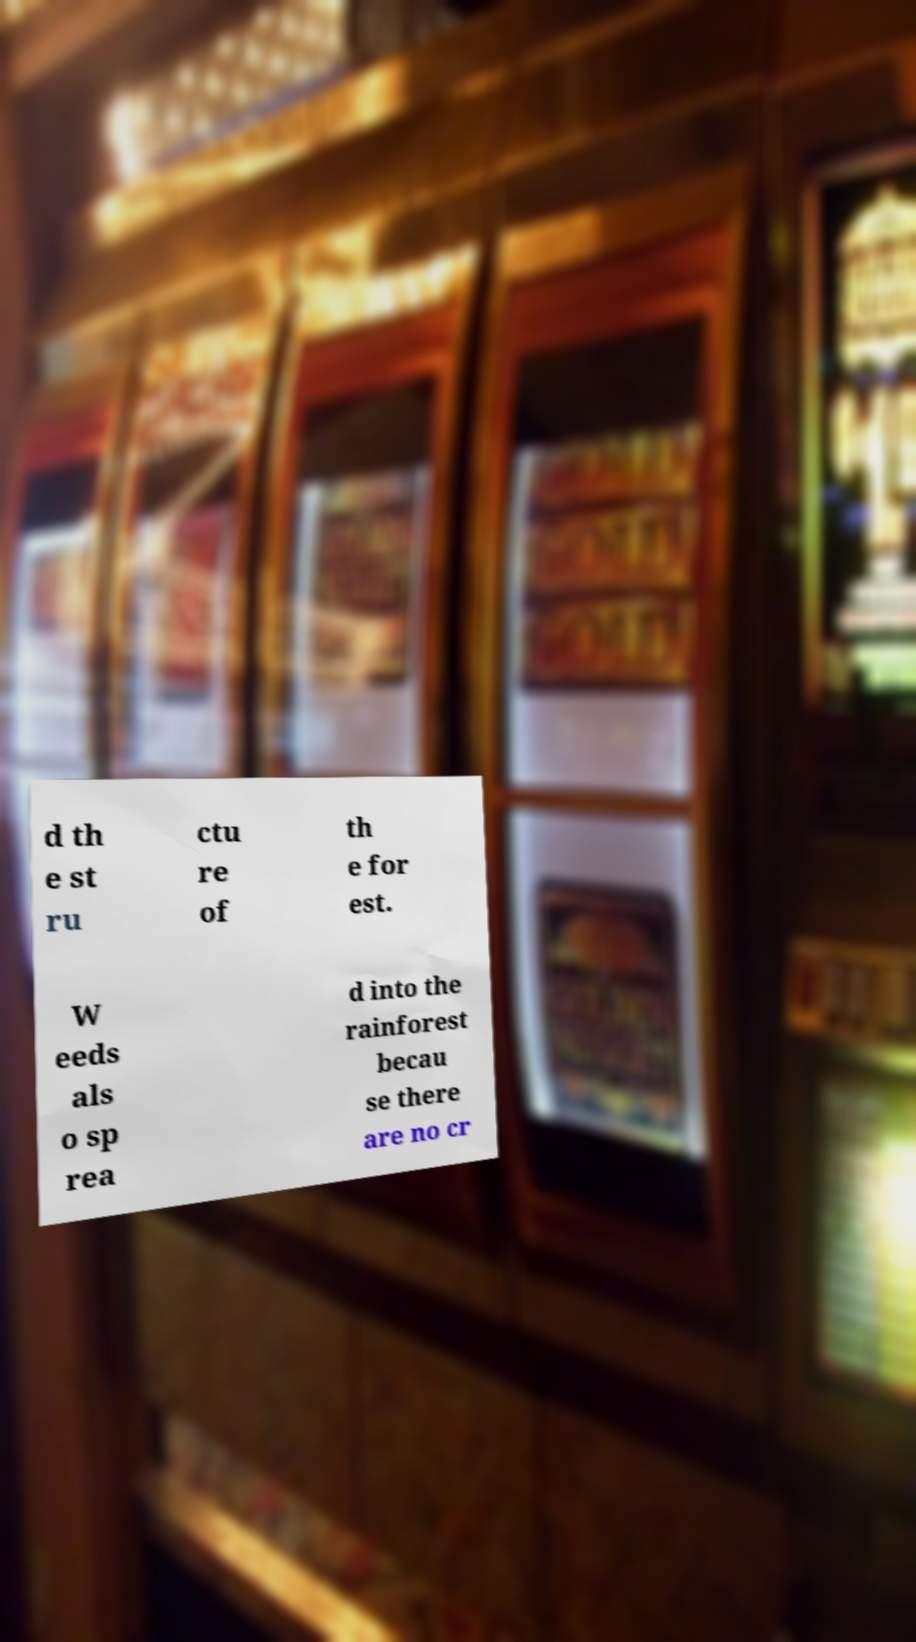There's text embedded in this image that I need extracted. Can you transcribe it verbatim? d th e st ru ctu re of th e for est. W eeds als o sp rea d into the rainforest becau se there are no cr 